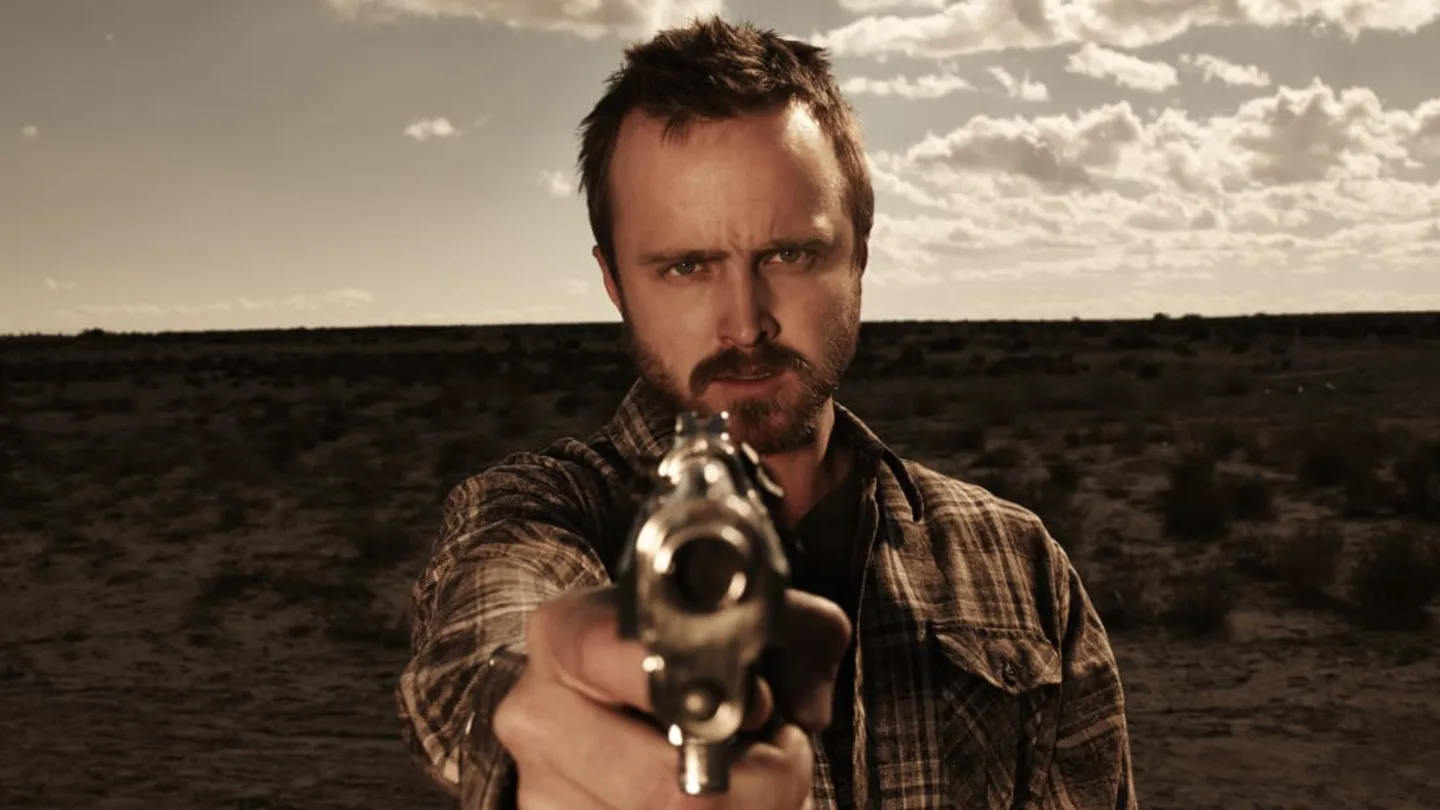Write a detailed description of the given image. The image captures a dramatic scene set in a desert landscape under a cloud-strewn sky. A man is positioned in the foreground, pointing a revolver directly at the camera. He has a focused and intense expression, with stubble on his face and short, dark hair. The man is wearing a plaid shirt, and the overall color tone of the image is a warm sepia, enhancing the gritty atmosphere of the scene. The vast and barren desert in the background contributes to a sense of isolation and suspense. 